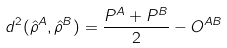<formula> <loc_0><loc_0><loc_500><loc_500>d ^ { 2 } ( \hat { \rho } ^ { A } , \hat { \rho } ^ { B } ) = \frac { P ^ { A } + P ^ { B } } { 2 } - O ^ { A B }</formula> 